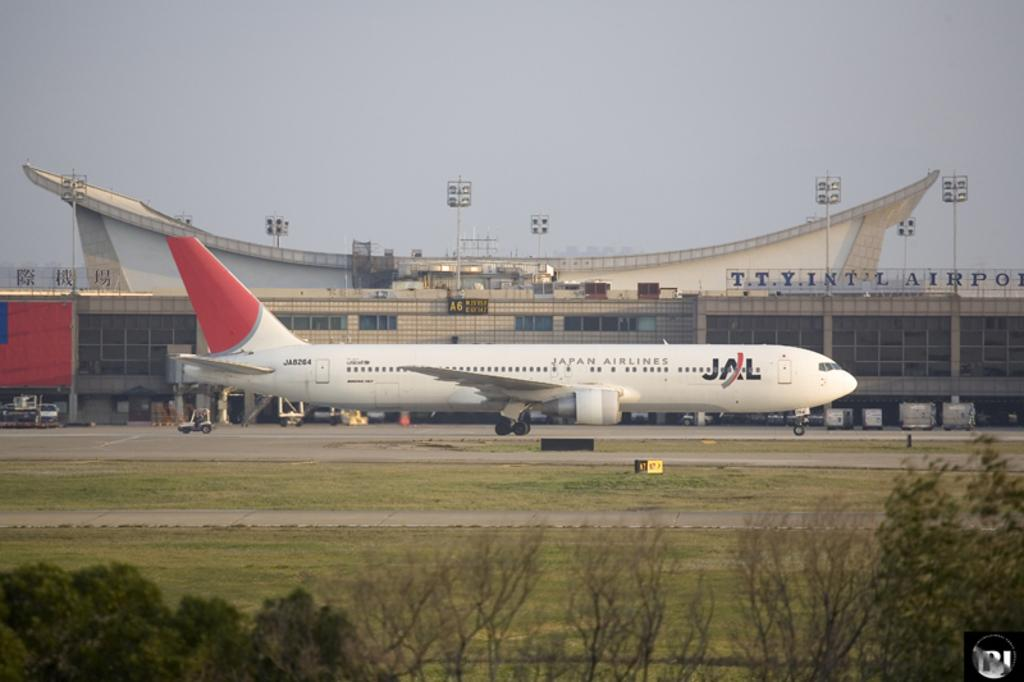<image>
Present a compact description of the photo's key features. an airplane grounded, with a JAL decal on the side 